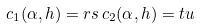Convert formula to latex. <formula><loc_0><loc_0><loc_500><loc_500>c _ { 1 } ( \alpha , h ) = r s \, c _ { 2 } ( \alpha , h ) = t u</formula> 